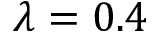Convert formula to latex. <formula><loc_0><loc_0><loc_500><loc_500>\lambda = 0 . 4</formula> 